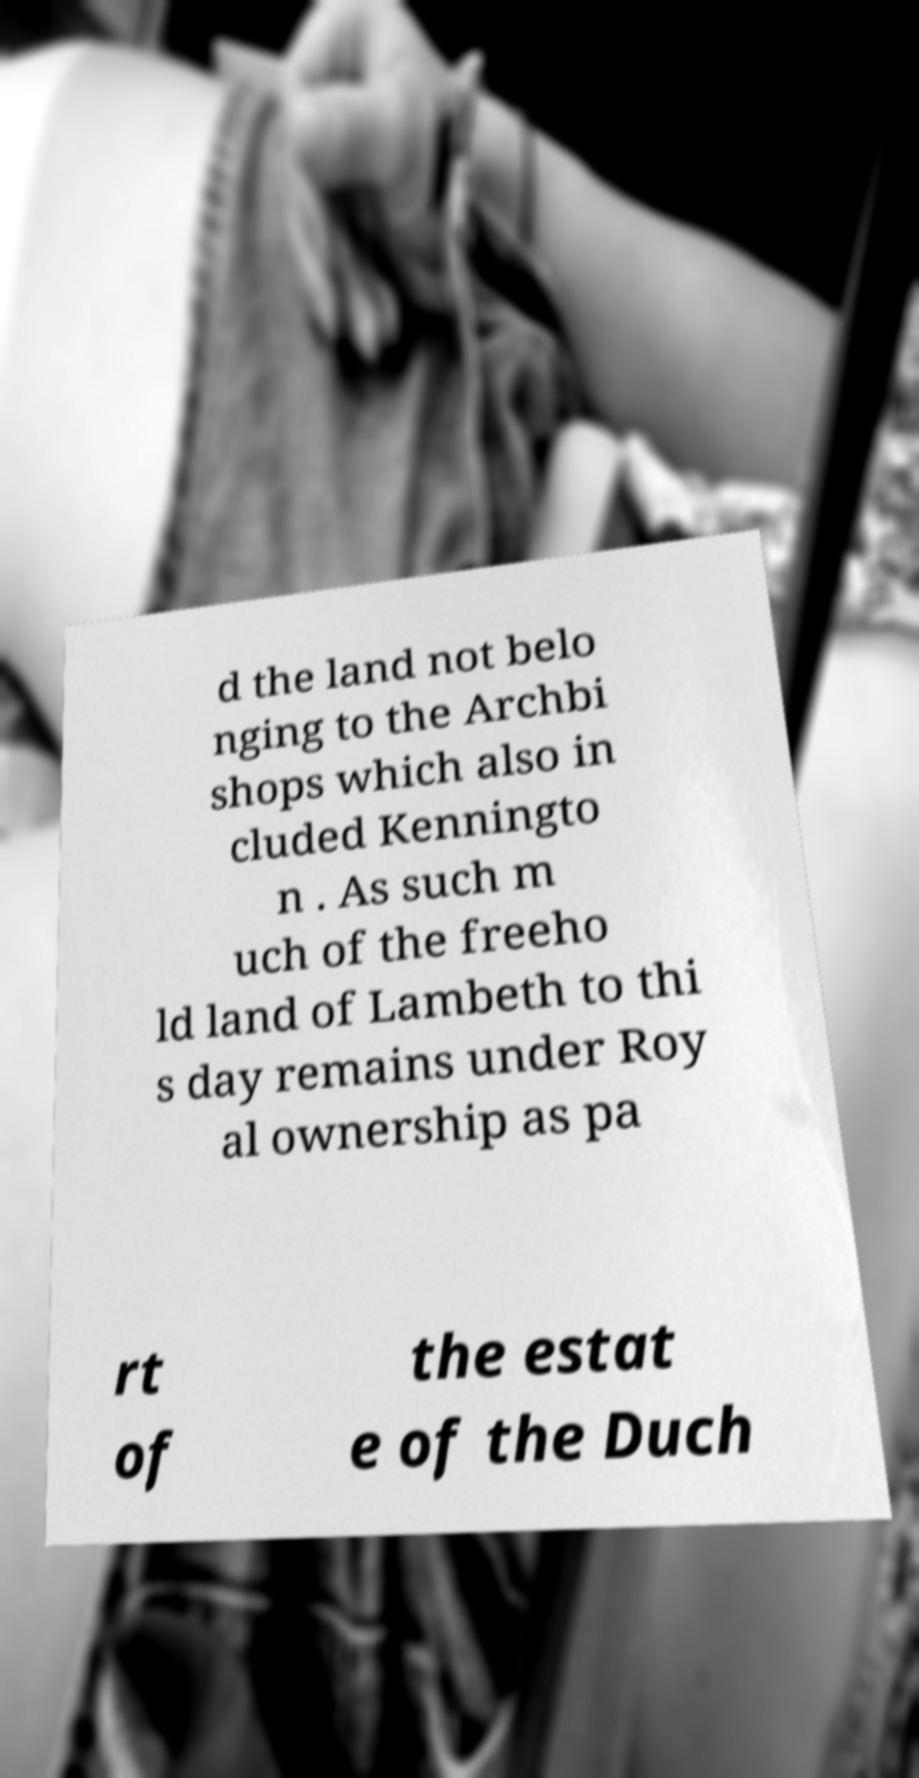Can you accurately transcribe the text from the provided image for me? d the land not belo nging to the Archbi shops which also in cluded Kenningto n . As such m uch of the freeho ld land of Lambeth to thi s day remains under Roy al ownership as pa rt of the estat e of the Duch 